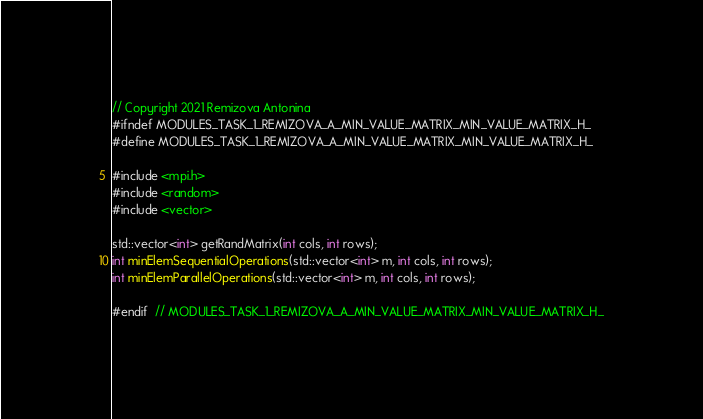Convert code to text. <code><loc_0><loc_0><loc_500><loc_500><_C_>// Copyright 2021 Remizova Antonina
#ifndef MODULES_TASK_1_REMIZOVA_A_MIN_VALUE_MATRIX_MIN_VALUE_MATRIX_H_
#define MODULES_TASK_1_REMIZOVA_A_MIN_VALUE_MATRIX_MIN_VALUE_MATRIX_H_

#include <mpi.h>
#include <random>
#include <vector>

std::vector<int> getRandMatrix(int cols, int rows);
int minElemSequentialOperations(std::vector<int> m, int cols, int rows);
int minElemParallelOperations(std::vector<int> m, int cols, int rows);

#endif  // MODULES_TASK_1_REMIZOVA_A_MIN_VALUE_MATRIX_MIN_VALUE_MATRIX_H_
</code> 